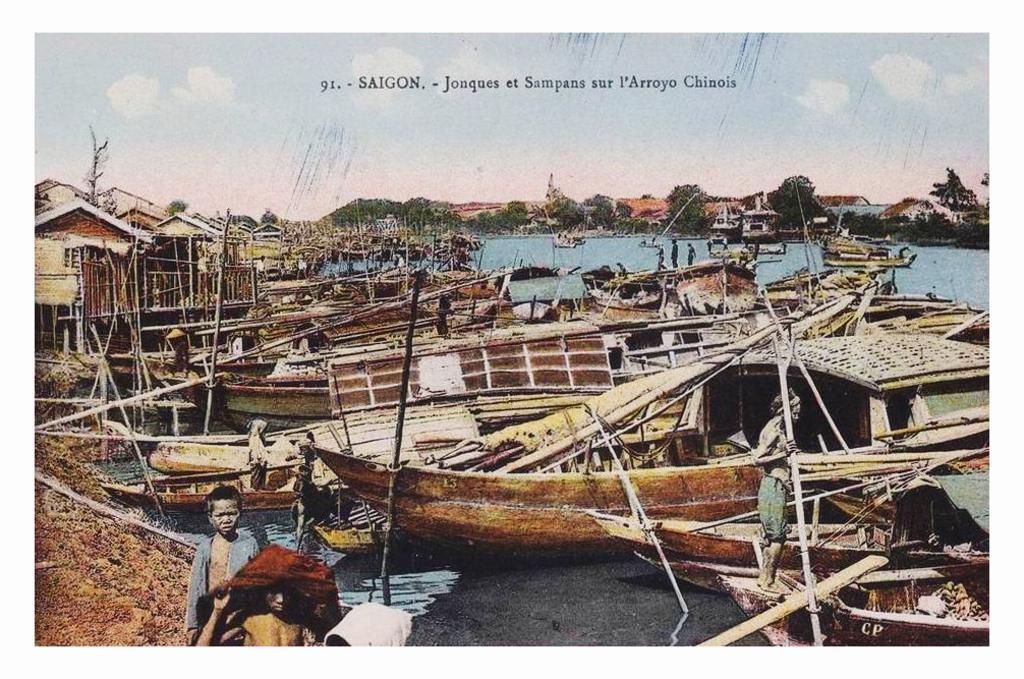In one or two sentences, can you explain what this image depicts? In this picture we can observe number of boats floating on the water. There are some people. We can observe houses on the left side. In the background there are trees and a sky with some clouds. We can observe black color text here. 